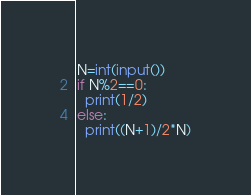<code> <loc_0><loc_0><loc_500><loc_500><_Python_>N=int(input())
if N%2==0:
  print(1/2)
else:
  print((N+1)/2*N)</code> 